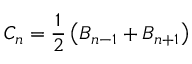<formula> <loc_0><loc_0><loc_500><loc_500>C _ { n } = \frac { 1 } { 2 } \left ( B _ { n - 1 } + B _ { n + 1 } \right )</formula> 